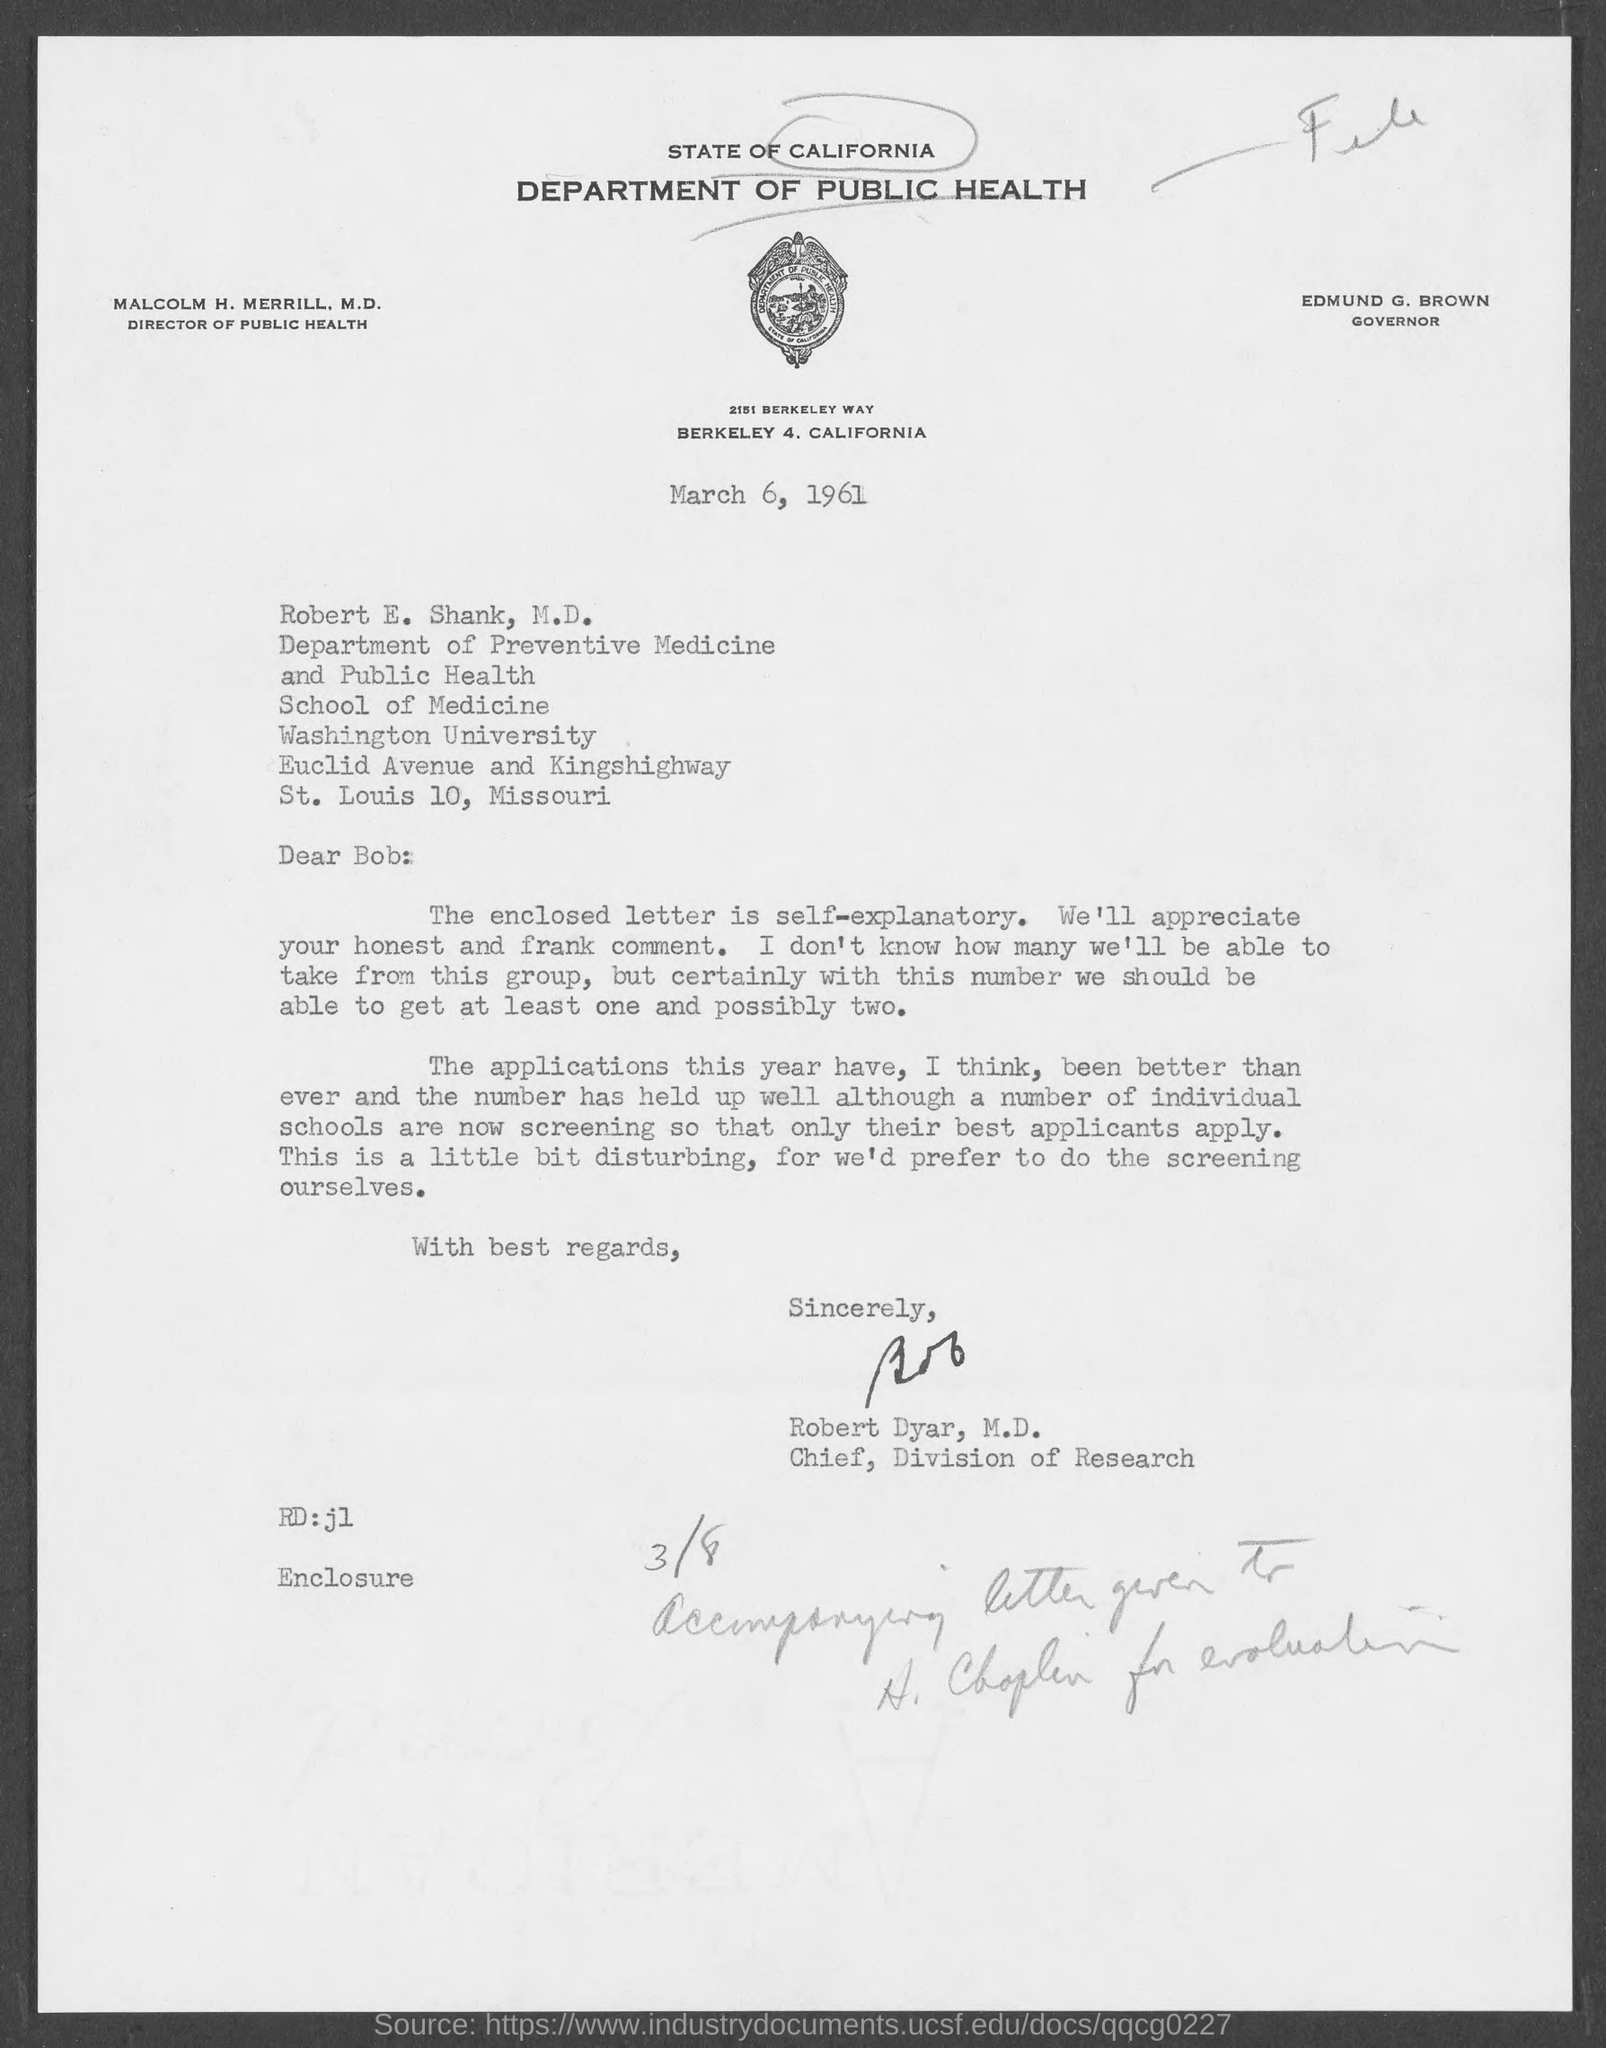Indicate a few pertinent items in this graphic. The Division of Research at the University of Washington is headed by Robert Dyar, M.D., who serves as the chief of the division. The writer of this letter is Robert Dyar, M.D. Edmund G. Brown is the current governor of the State of California. The Director of Public Health for the State of California is Malcolm H. Merrill, M.D. 